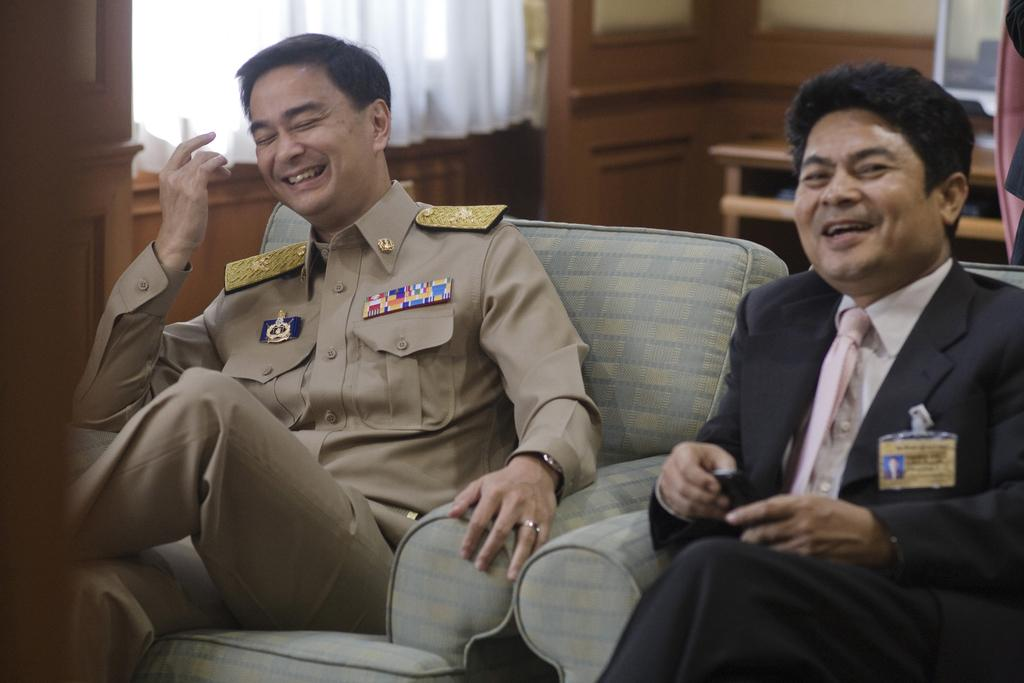How many men are in the image? There are two men in the image. Where is each man located in relation to the other? One man is on the right side of the image, and the other is on the left side. What are the men doing in the image? Both men are sitting on a sofa. What can be seen in the background of the image? There is a table, a portrait, and a curtain in the background of the image. What arithmetic problem is the man on the right side of the image solving? There is no indication in the image that the man on the right side is solving an arithmetic problem. 